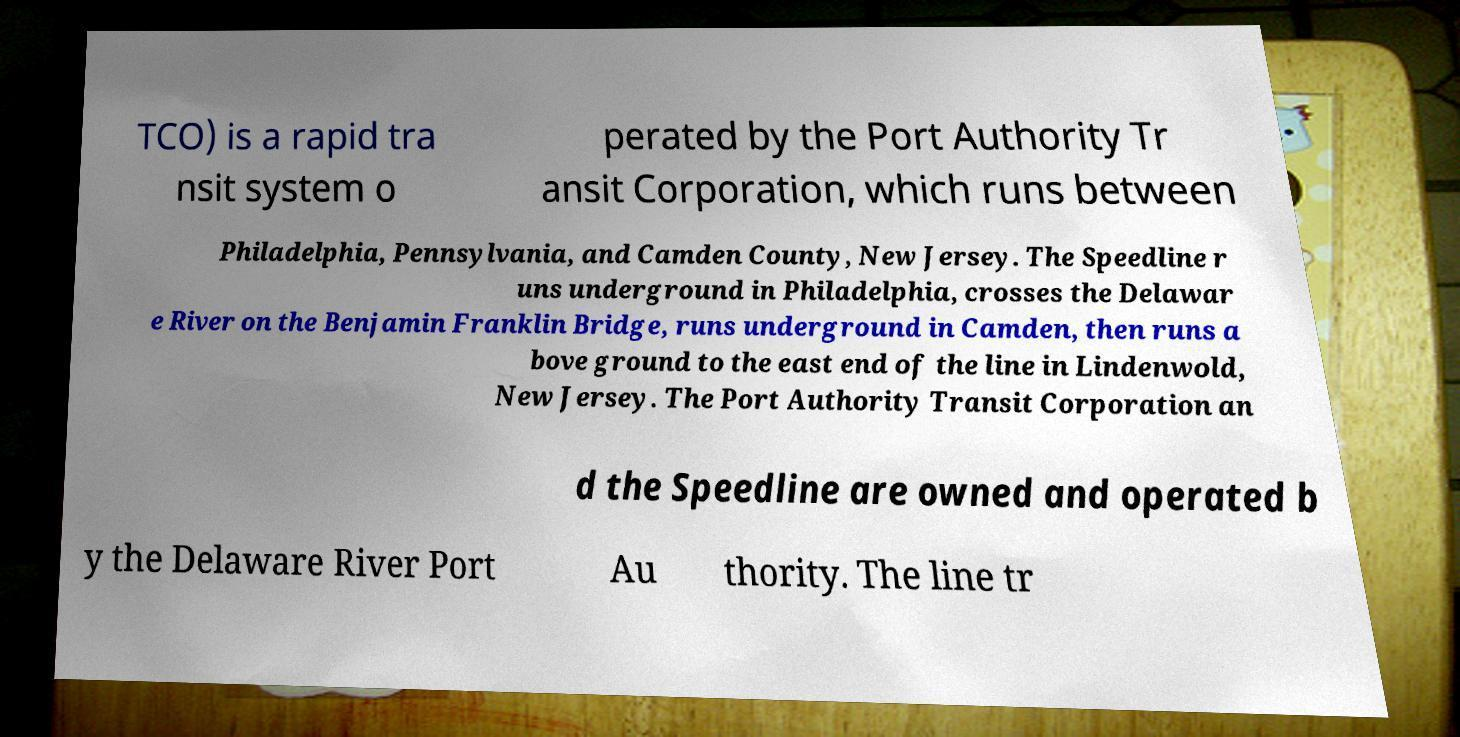I need the written content from this picture converted into text. Can you do that? TCO) is a rapid tra nsit system o perated by the Port Authority Tr ansit Corporation, which runs between Philadelphia, Pennsylvania, and Camden County, New Jersey. The Speedline r uns underground in Philadelphia, crosses the Delawar e River on the Benjamin Franklin Bridge, runs underground in Camden, then runs a bove ground to the east end of the line in Lindenwold, New Jersey. The Port Authority Transit Corporation an d the Speedline are owned and operated b y the Delaware River Port Au thority. The line tr 